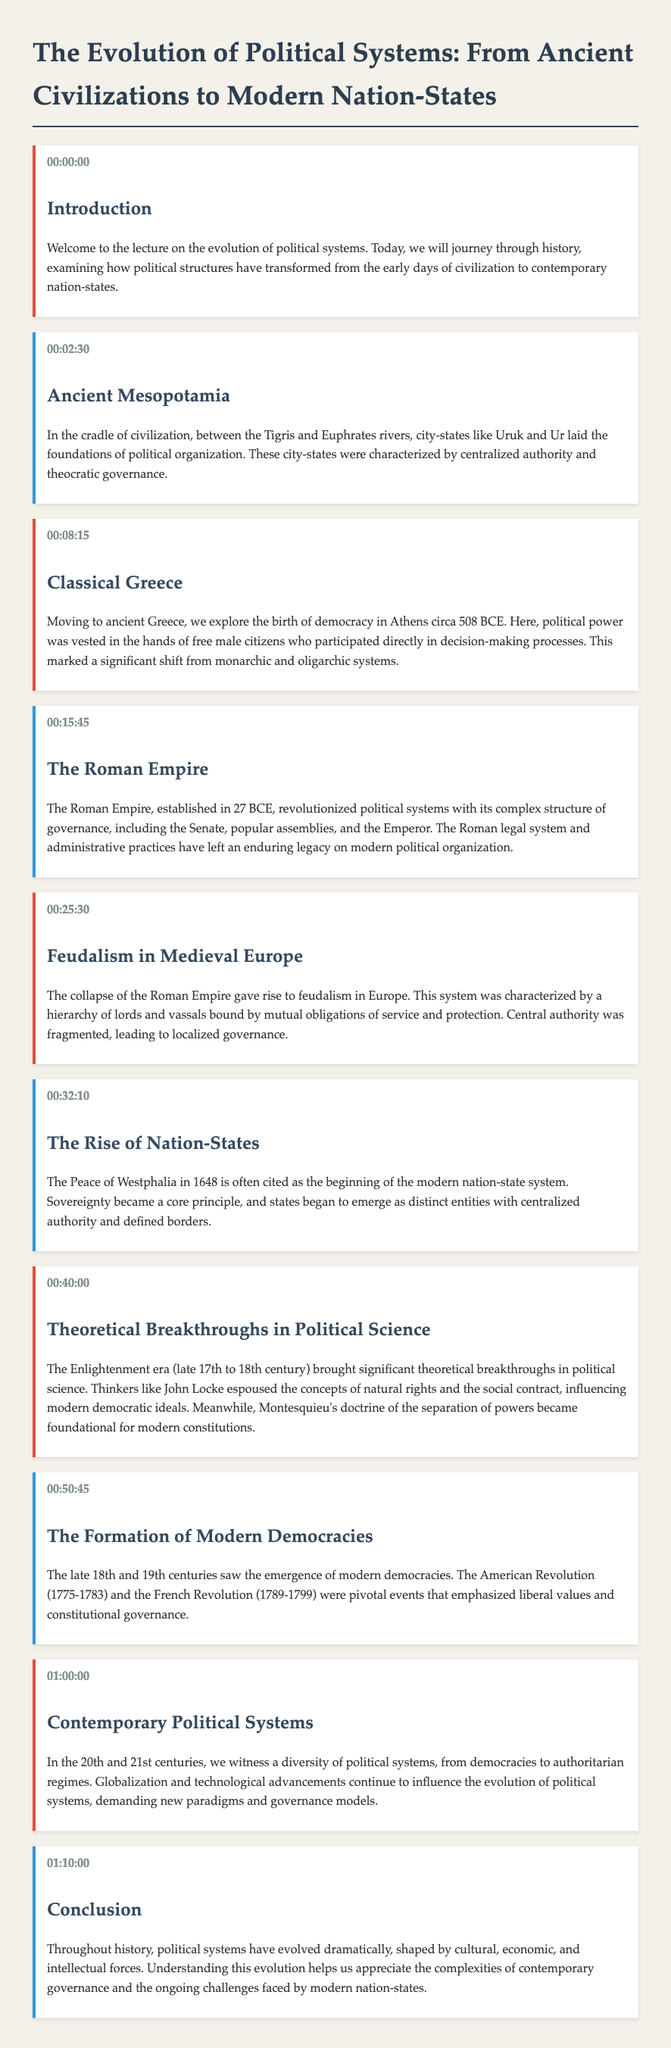What time does the lecture begin? The lecture begins at timestamp 00:00:00, indicating the start of the content.
Answer: 00:00:00 What was a key characteristic of ancient Mesopotamia's political organization? The document states that city-states like Uruk and Ur had centralized authority and theocratic governance.
Answer: Centralized authority and theocratic governance When was democracy first established in Athens? The lecture mentions that democracy in Athens began circa 508 BCE.
Answer: Circa 508 BCE What historical event is linked with the beginning of the modern nation-state system? The document cites the Peace of Westphalia in 1648 as the beginning of the modern nation-state system.
Answer: Peace of Westphalia in 1648 Which thinker is associated with the concept of the social contract during the Enlightenment? The lecture lists John Locke as a key thinker who espoused the social contract.
Answer: John Locke What two revolutions are highlighted as pivotal for modern democracies? The document emphasizes the American Revolution and the French Revolution as significant events.
Answer: American Revolution and French Revolution What is the duration of the lecture according to the timestamps? The lecture spans from the start at 00:00:00 to the conclusion at 01:10:00, indicating it is 70 minutes long.
Answer: 70 minutes What did Montesquieu contribute to modern political thought? Montesquieu's doctrine of the separation of powers is noted as foundational for modern constitutions in the lecture.
Answer: Separation of powers What changes are affecting political systems in the 21st century? The lecture mentions globalization and technological advancements as influencing factors.
Answer: Globalization and technological advancements 